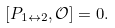Convert formula to latex. <formula><loc_0><loc_0><loc_500><loc_500>[ P _ { 1 \leftrightarrow 2 } , \mathcal { O } ] = 0 .</formula> 